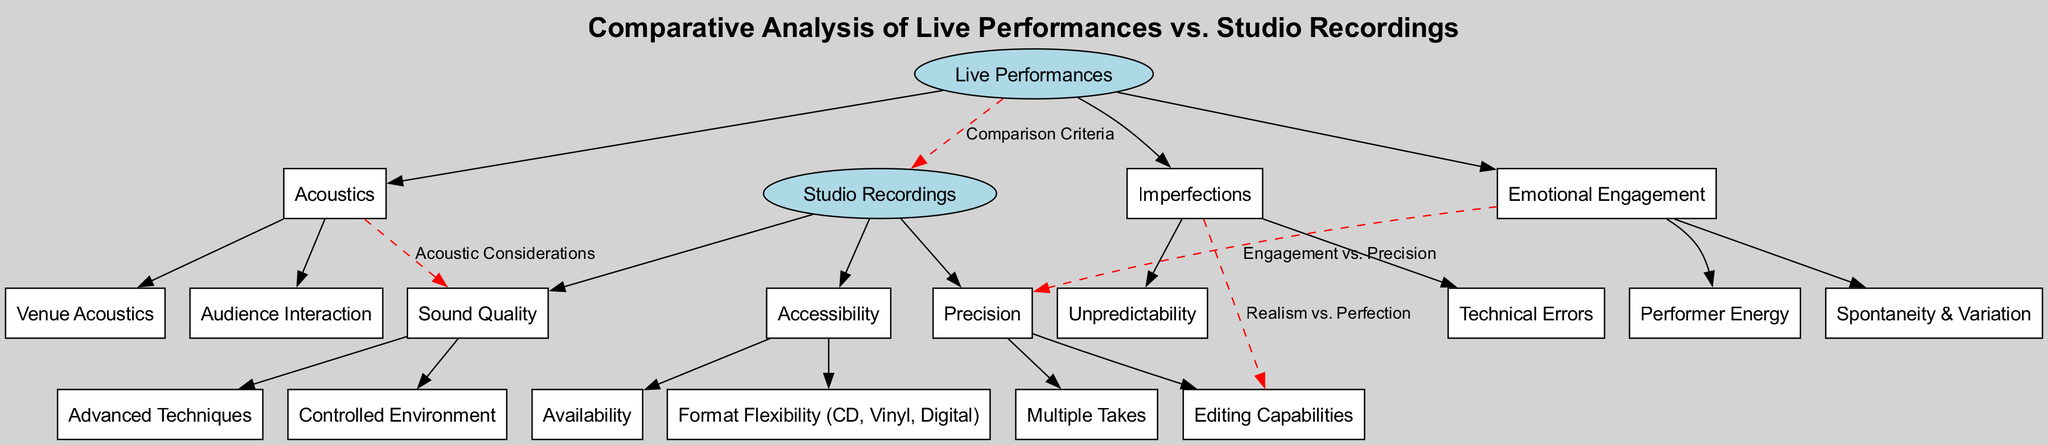What are the three main components of live performances? The diagram lists "Acoustics," "Emotional Engagement," and "Imperfections" as the main components of live performances.
Answer: Acoustics, Emotional Engagement, Imperfections How many nodes are there in total in the diagram? Counting all the nodes, including main nodes and their children, there are 11 nodes in total.
Answer: 11 What connection is represented between live performances and studio recordings? The connection indicates the shared criteria for comparison, labeled "Comparison Criteria."
Answer: Comparison Criteria Which aspect of studio recordings relates to availability? The node linked to availability is "Accessibility," which indicates how studio recordings can be accessed.
Answer: Accessibility How does emotional engagement relate to precision? The diagram specifies that emotional engagement is compared to precision, suggesting a relationship between these two ideas as indicated by the dashed edge connecting them.
Answer: Engagement vs. Precision What is a key feature of studio recordings linked to sound quality? "Controlled Environment" is a specific child node under "Sound Quality," indicating that a studio offers a controlled environment for recording music.
Answer: Controlled Environment What are the types of imperfections mentioned in live performances? The two types listed are "Technical Errors" and "Unpredictability."
Answer: Technical Errors, Unpredictability What advanced technique is associated with studio recordings? "Advanced Techniques" is a child node under "Sound Quality," emphasizing that these techniques are a feature of studio recordings.
Answer: Advanced Techniques Which component of live performances emphasizes audience interaction? "Acoustics" is the component that includes "Audience Interaction" as one of its specific child aspects.
Answer: Acoustics What is the relationship denoted between imperfections and editing capabilities? The connection represents a contrast between "Realism vs. Perfection," suggesting that imperfections in live performances contrast with the perfection achieved through editing in studio recordings.
Answer: Realism vs. Perfection 